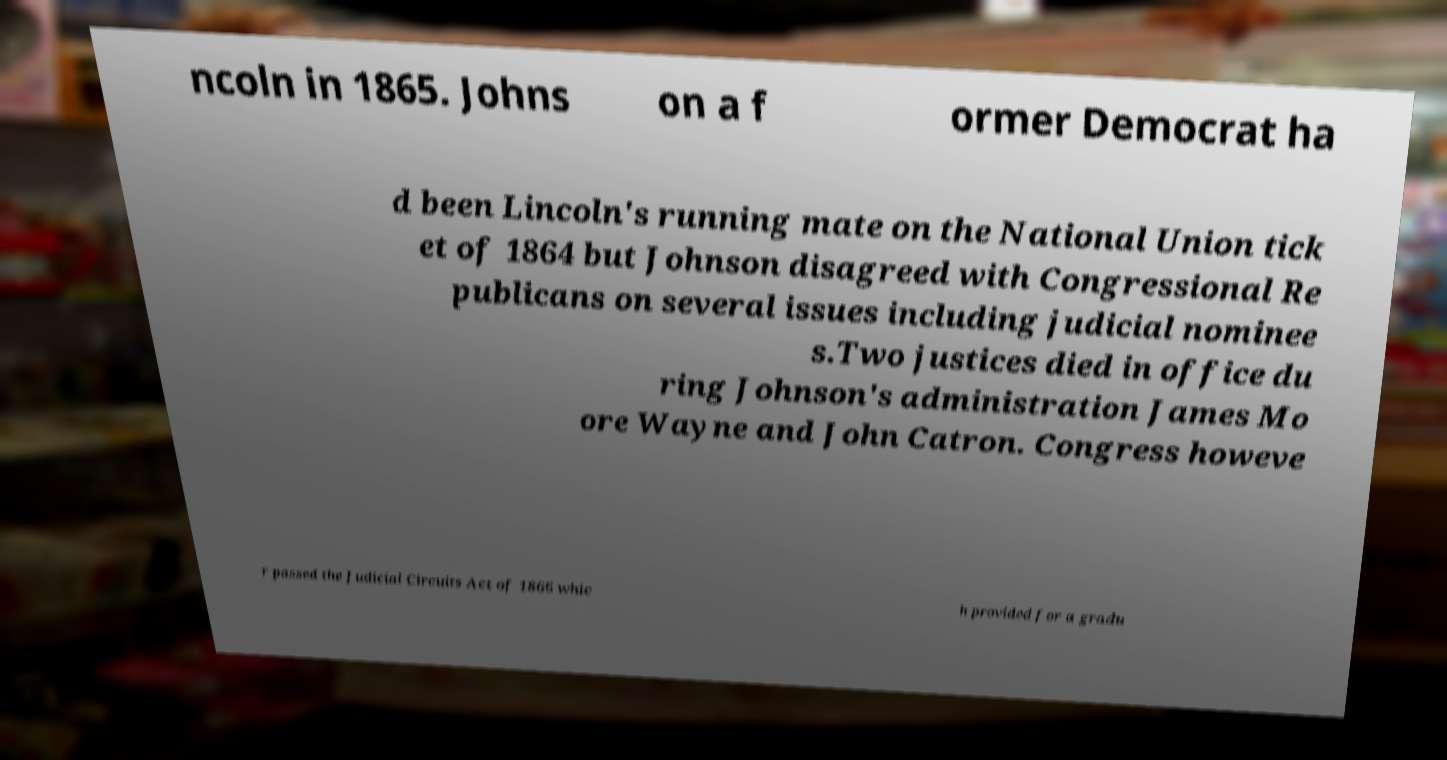I need the written content from this picture converted into text. Can you do that? ncoln in 1865. Johns on a f ormer Democrat ha d been Lincoln's running mate on the National Union tick et of 1864 but Johnson disagreed with Congressional Re publicans on several issues including judicial nominee s.Two justices died in office du ring Johnson's administration James Mo ore Wayne and John Catron. Congress howeve r passed the Judicial Circuits Act of 1866 whic h provided for a gradu 